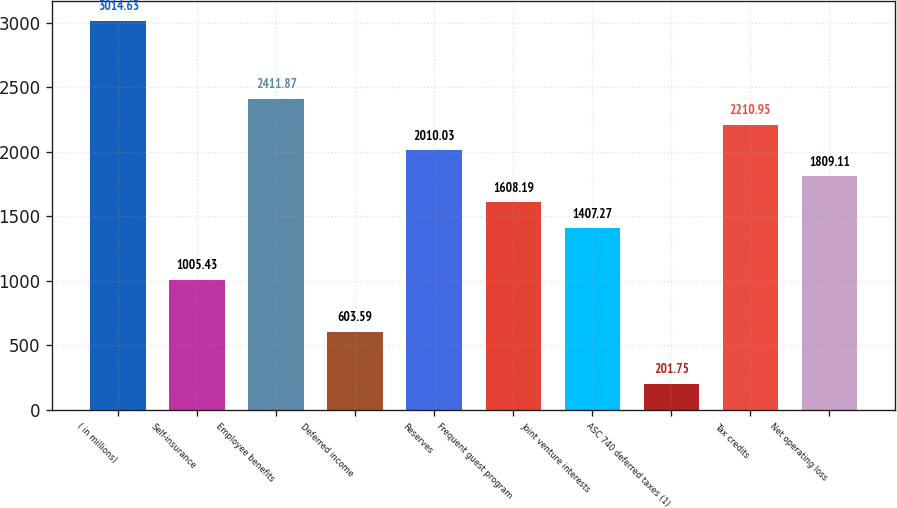<chart> <loc_0><loc_0><loc_500><loc_500><bar_chart><fcel>( in millions)<fcel>Self-insurance<fcel>Employee benefits<fcel>Deferred income<fcel>Reserves<fcel>Frequent guest program<fcel>Joint venture interests<fcel>ASC 740 deferred taxes (1)<fcel>Tax credits<fcel>Net operating loss<nl><fcel>3014.63<fcel>1005.43<fcel>2411.87<fcel>603.59<fcel>2010.03<fcel>1608.19<fcel>1407.27<fcel>201.75<fcel>2210.95<fcel>1809.11<nl></chart> 